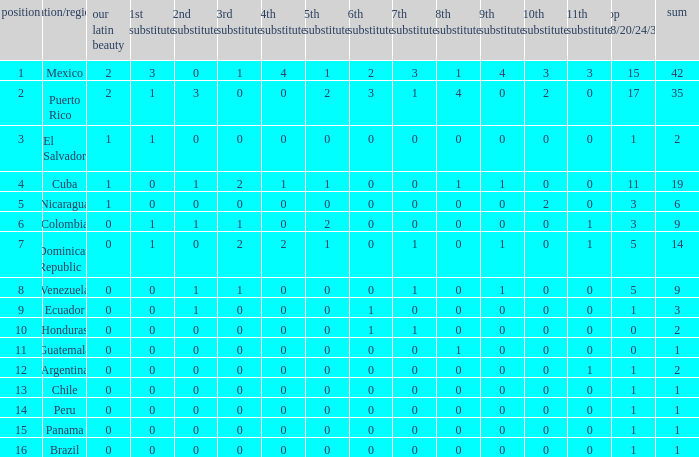What is the 9th runner-up with a top 18/20/24/30 greater than 17 and a 5th runner-up of 2? None. 